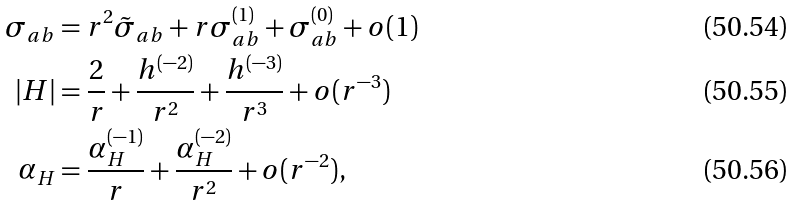<formula> <loc_0><loc_0><loc_500><loc_500>\sigma _ { a b } & = r ^ { 2 } \tilde { \sigma } _ { a b } + r \sigma _ { a b } ^ { ( 1 ) } + \sigma _ { a b } ^ { ( 0 ) } + o ( 1 ) \\ | H | & = \frac { 2 } { r } + \frac { h ^ { ( - 2 ) } } { r ^ { 2 } } + \frac { h ^ { ( - 3 ) } } { r ^ { 3 } } + o ( r ^ { - 3 } ) \\ \alpha _ { H } & = \frac { \alpha _ { H } ^ { ( - 1 ) } } { r } + \frac { \alpha _ { H } ^ { ( - 2 ) } } { r ^ { 2 } } + o ( r ^ { - 2 } ) ,</formula> 